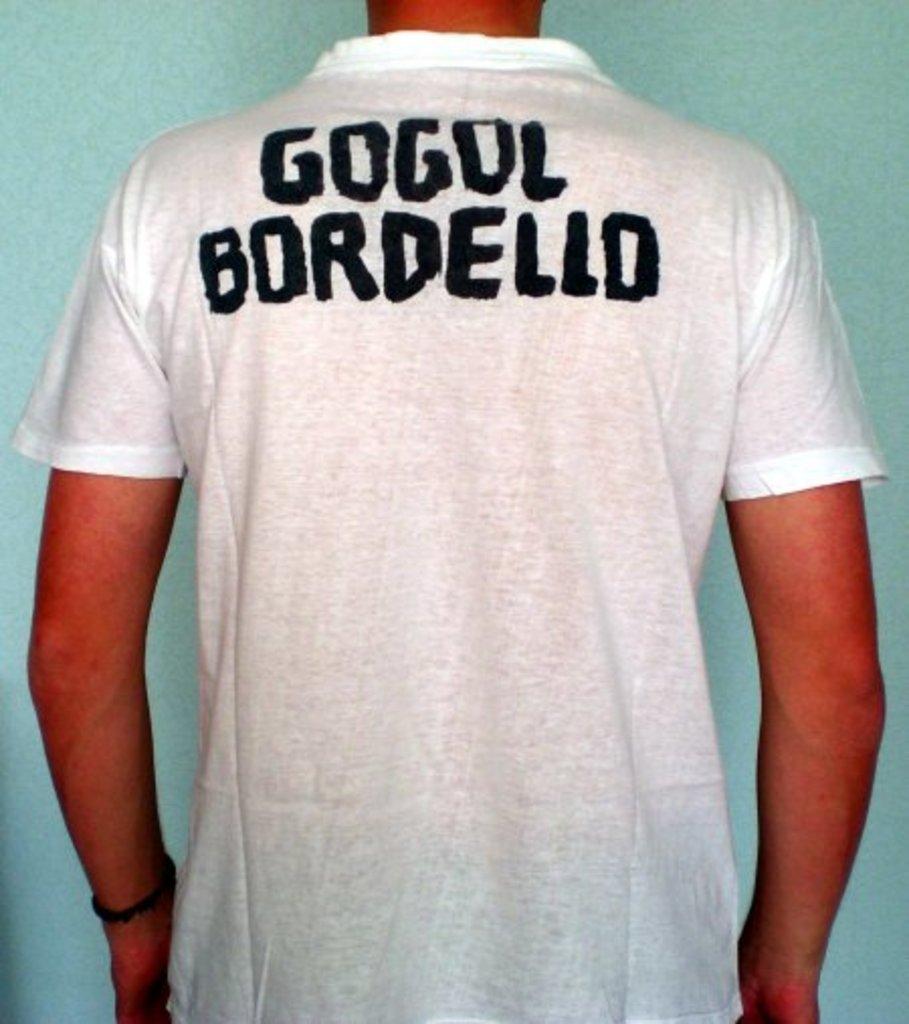What is on the back of the shirt?
Provide a short and direct response. Gogol bordello. What name is on the shirt?
Provide a succinct answer. Gogol bordello. 